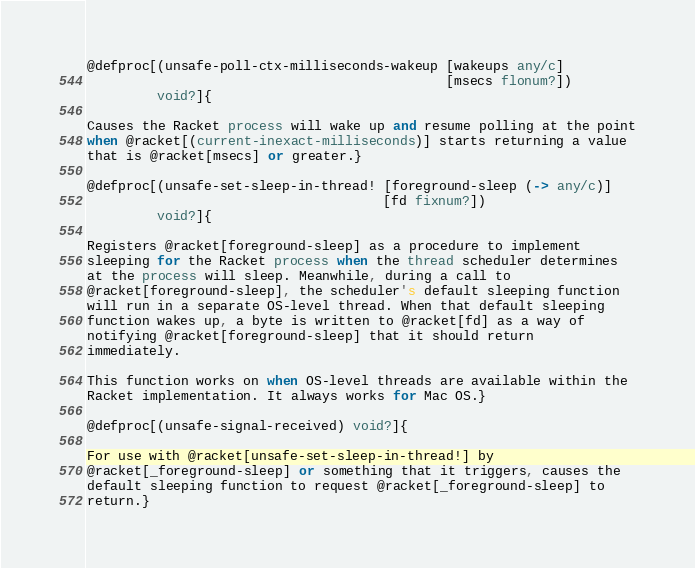Convert code to text. <code><loc_0><loc_0><loc_500><loc_500><_Racket_>@defproc[(unsafe-poll-ctx-milliseconds-wakeup [wakeups any/c]
                                              [msecs flonum?])
         void?]{

Causes the Racket process will wake up and resume polling at the point
when @racket[(current-inexact-milliseconds)] starts returning a value
that is @racket[msecs] or greater.}

@defproc[(unsafe-set-sleep-in-thread! [foreground-sleep (-> any/c)]
                                      [fd fixnum?])
         void?]{

Registers @racket[foreground-sleep] as a procedure to implement
sleeping for the Racket process when the thread scheduler determines
at the process will sleep. Meanwhile, during a call to
@racket[foreground-sleep], the scheduler's default sleeping function
will run in a separate OS-level thread. When that default sleeping
function wakes up, a byte is written to @racket[fd] as a way of
notifying @racket[foreground-sleep] that it should return
immediately.

This function works on when OS-level threads are available within the
Racket implementation. It always works for Mac OS.}

@defproc[(unsafe-signal-received) void?]{

For use with @racket[unsafe-set-sleep-in-thread!] by
@racket[_foreground-sleep] or something that it triggers, causes the
default sleeping function to request @racket[_foreground-sleep] to
return.}
</code> 